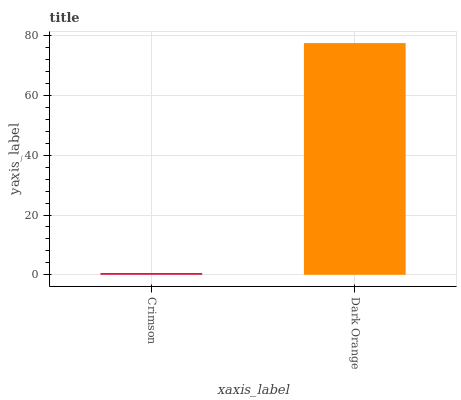Is Crimson the minimum?
Answer yes or no. Yes. Is Dark Orange the maximum?
Answer yes or no. Yes. Is Dark Orange the minimum?
Answer yes or no. No. Is Dark Orange greater than Crimson?
Answer yes or no. Yes. Is Crimson less than Dark Orange?
Answer yes or no. Yes. Is Crimson greater than Dark Orange?
Answer yes or no. No. Is Dark Orange less than Crimson?
Answer yes or no. No. Is Dark Orange the high median?
Answer yes or no. Yes. Is Crimson the low median?
Answer yes or no. Yes. Is Crimson the high median?
Answer yes or no. No. Is Dark Orange the low median?
Answer yes or no. No. 